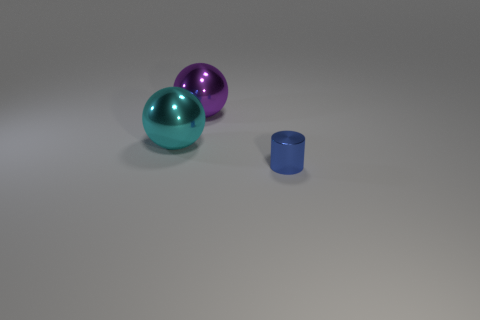How many objects are either small blue rubber things or shiny objects that are to the right of the cyan sphere?
Your answer should be compact. 2. How many other objects are there of the same shape as the blue object?
Give a very brief answer. 0. Are there fewer large metal objects that are to the right of the small blue metal thing than objects behind the cyan object?
Your answer should be very brief. Yes. Is there any other thing that has the same material as the purple object?
Ensure brevity in your answer.  Yes. What shape is the other cyan thing that is the same material as the small object?
Provide a short and direct response. Sphere. Are there any other things of the same color as the tiny metal object?
Your answer should be very brief. No. There is a shiny ball behind the shiny ball in front of the big purple metallic object; what color is it?
Provide a succinct answer. Purple. What is the purple ball that is right of the big thing in front of the thing behind the cyan shiny ball made of?
Keep it short and to the point. Metal. How many cylinders are the same size as the cyan shiny thing?
Ensure brevity in your answer.  0. There is a object that is both on the right side of the big cyan ball and in front of the purple ball; what material is it?
Your answer should be compact. Metal. 